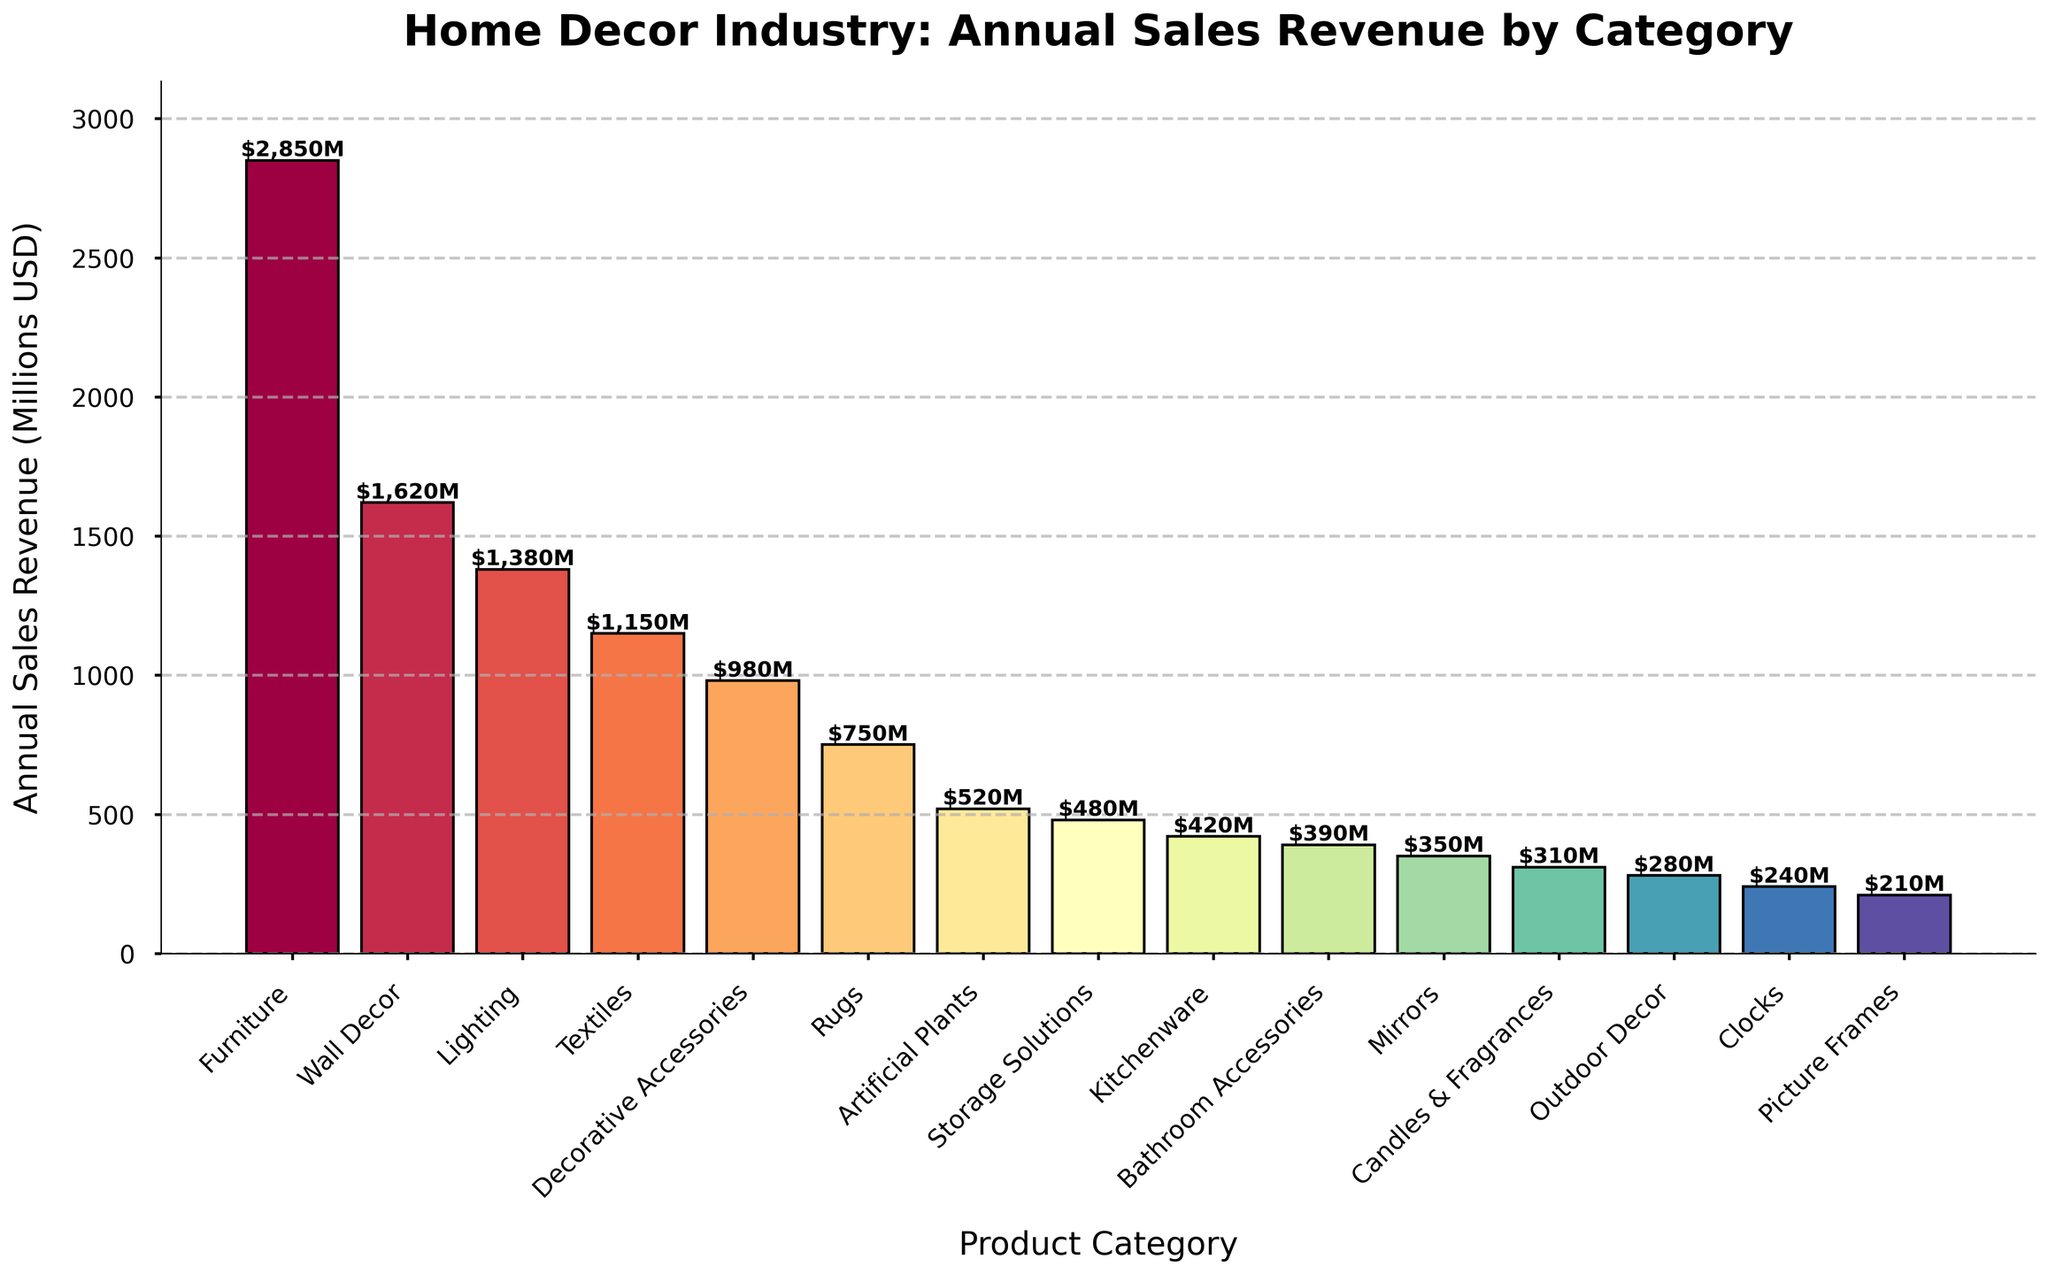Which product category has the highest annual sales revenue? By looking at the height of the bars, identify the bar with the maximum height. Furniture has the highest annual sales revenue.
Answer: Furniture Which product category has the lowest annual sales revenue? By looking at the height of the bars, identify the bar with the minimum height. Picture Frames has the lowest annual sales revenue.
Answer: Picture Frames How much more revenue does Furniture generate compared to Rugs? Subtract the annual sales revenue of Rugs from that of Furniture: 2850M - 750M.
Answer: 2100M What is the combined annual revenue of Lighting, Textiles, and Decorative Accessories? Add the annual sales revenues of Lighting, Textiles, and Decorative Accessories: 1380M + 1150M + 980M.
Answer: 3510M Which product category generates more revenue: Wall Decor or Mirrors? Compare the annual sales revenues of Wall Decor and Mirrors: 1620M vs. 350M. Wall Decor generates more revenue.
Answer: Wall Decor Which categories fall below the 500 million USD annual sales revenue mark? Identify all bars with heights less than 500: Artificial Plants, Storage Solutions, Kitchenware, Bathroom Accessories, Mirrors, Candles & Fragrances, Outdoor Decor, Clocks, Picture Frames.
Answer: Artificial Plants, Storage Solutions, Kitchenware, Bathroom Accessories, Mirrors, Candles & Fragrances, Outdoor Decor, Clocks, Picture Frames What's the average annual sales revenue of the top five categories? Sum the annual sales revenues of Furniture, Wall Decor, Lighting, Textiles, and Decorative Accessories, and divide by 5: (2850M + 1620M + 1380M + 1150M + 980M) / 5.
Answer: 1396M Is the annual revenue of Rugs closer to that of Artificial Plants or to Kitchenware? Calculate the absolute differences: Rugs to Artificial Plants (750M - 520M) = 230M, Rugs to Kitchenware (750M - 420M) = 330M. Rugs is closer to Artificial Plants.
Answer: Artificial Plants How does the revenue of Candles & Fragrances compare to Bathroom Accessories? Compare the annual sales revenues of Candles & Fragrances and Bathroom Accessories: 310M vs. 390M. Bathroom Accessories generates more revenue.
Answer: Bathroom Accessories What is the proportion of Furniture's annual sales revenue to the total annual sales revenue? Sum all annual sales revenues, then divide Furniture's revenue by this total and multiply by 100 to get the percentage: Total = 16200M; (2850M / 16200M) * 100.
Answer: 17.6% 